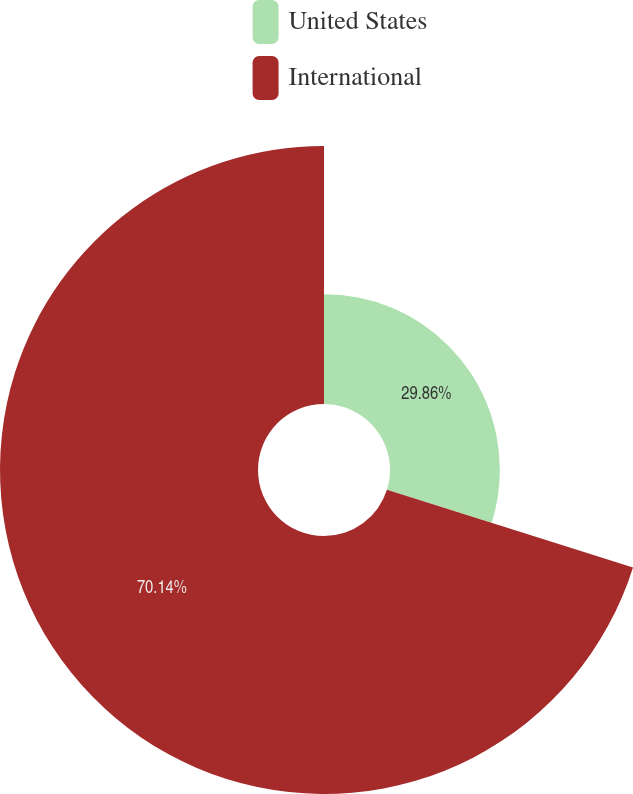<chart> <loc_0><loc_0><loc_500><loc_500><pie_chart><fcel>United States<fcel>International<nl><fcel>29.86%<fcel>70.14%<nl></chart> 